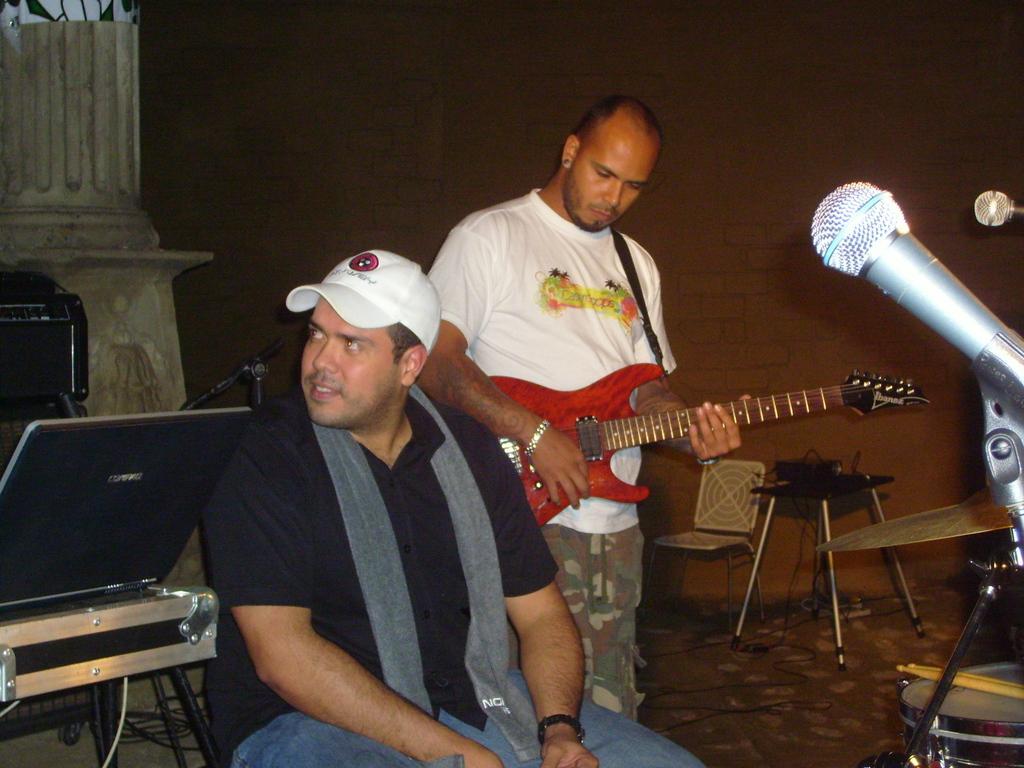Could you give a brief overview of what you see in this image? On the background of the picture we can see a wall with bricks. Here we can see a man wearing a white shirt standing in front of a mike and playing guitar. Here we can see one man sitting and wearing a white color cap and a black colour tshirt and an ash color scarf around his neck. This is a laptop and it's an electronic device. 